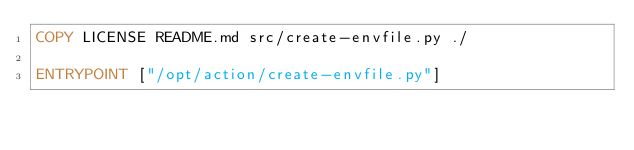Convert code to text. <code><loc_0><loc_0><loc_500><loc_500><_Dockerfile_>COPY LICENSE README.md src/create-envfile.py ./

ENTRYPOINT ["/opt/action/create-envfile.py"]
</code> 